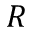<formula> <loc_0><loc_0><loc_500><loc_500>R</formula> 